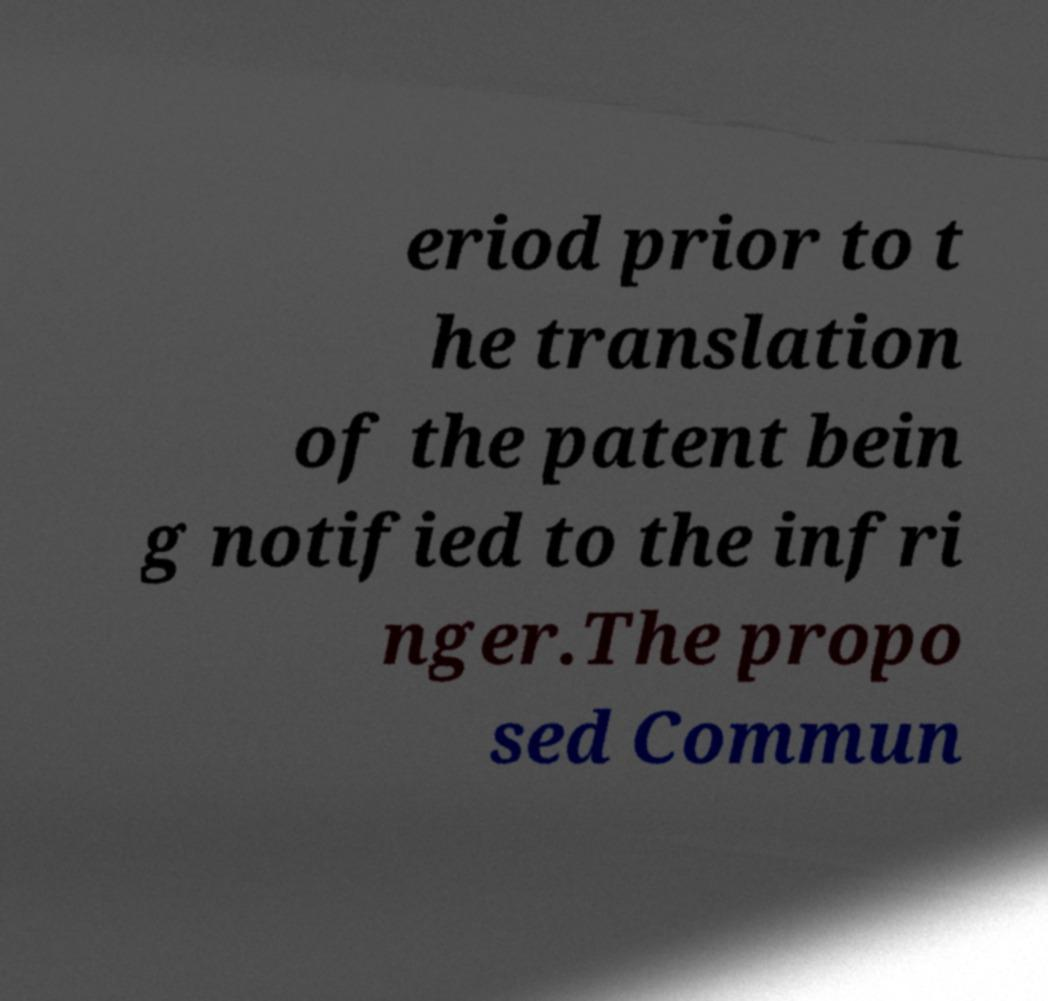Could you extract and type out the text from this image? eriod prior to t he translation of the patent bein g notified to the infri nger.The propo sed Commun 